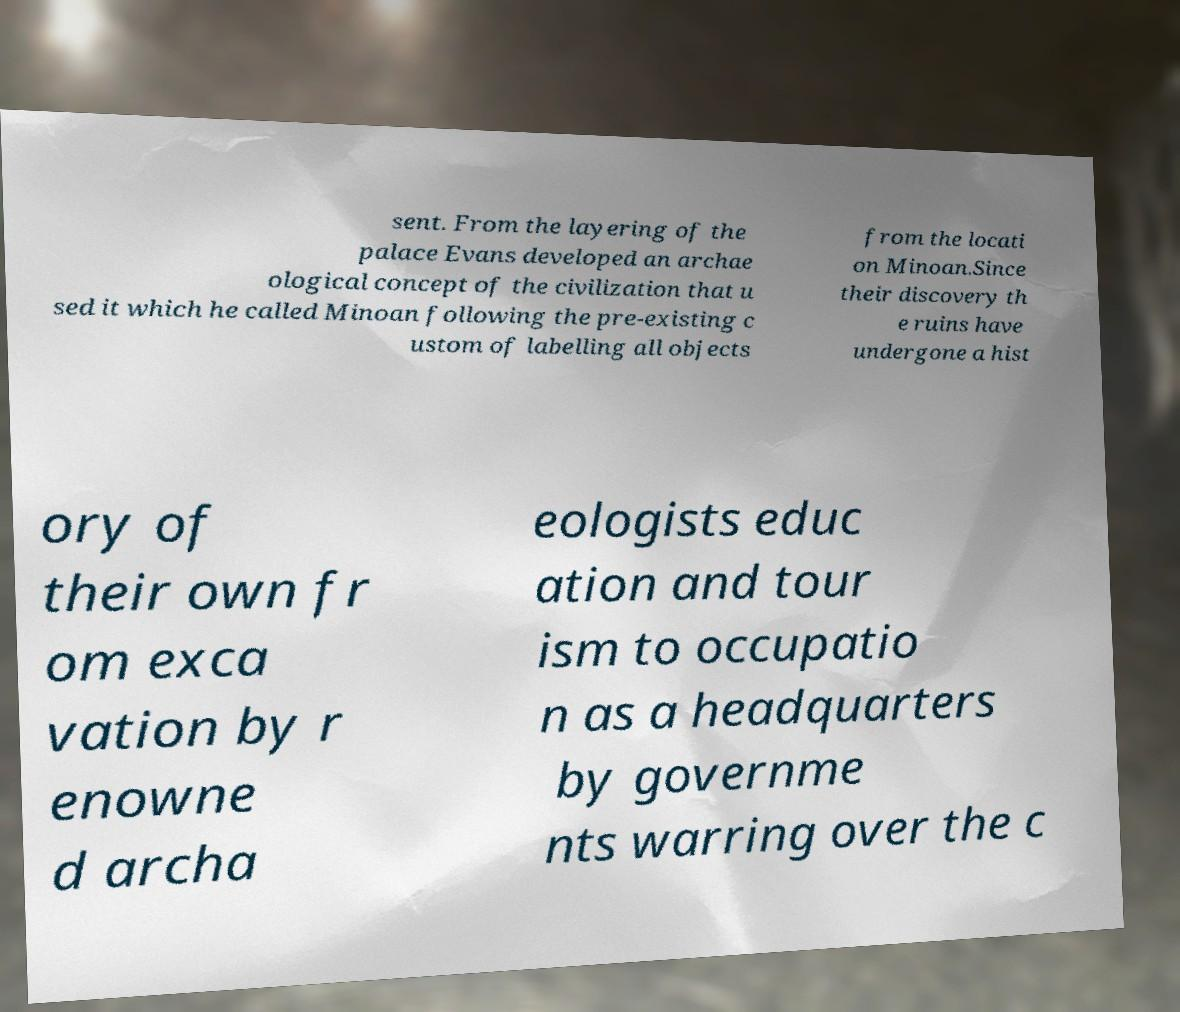I need the written content from this picture converted into text. Can you do that? sent. From the layering of the palace Evans developed an archae ological concept of the civilization that u sed it which he called Minoan following the pre-existing c ustom of labelling all objects from the locati on Minoan.Since their discovery th e ruins have undergone a hist ory of their own fr om exca vation by r enowne d archa eologists educ ation and tour ism to occupatio n as a headquarters by governme nts warring over the c 